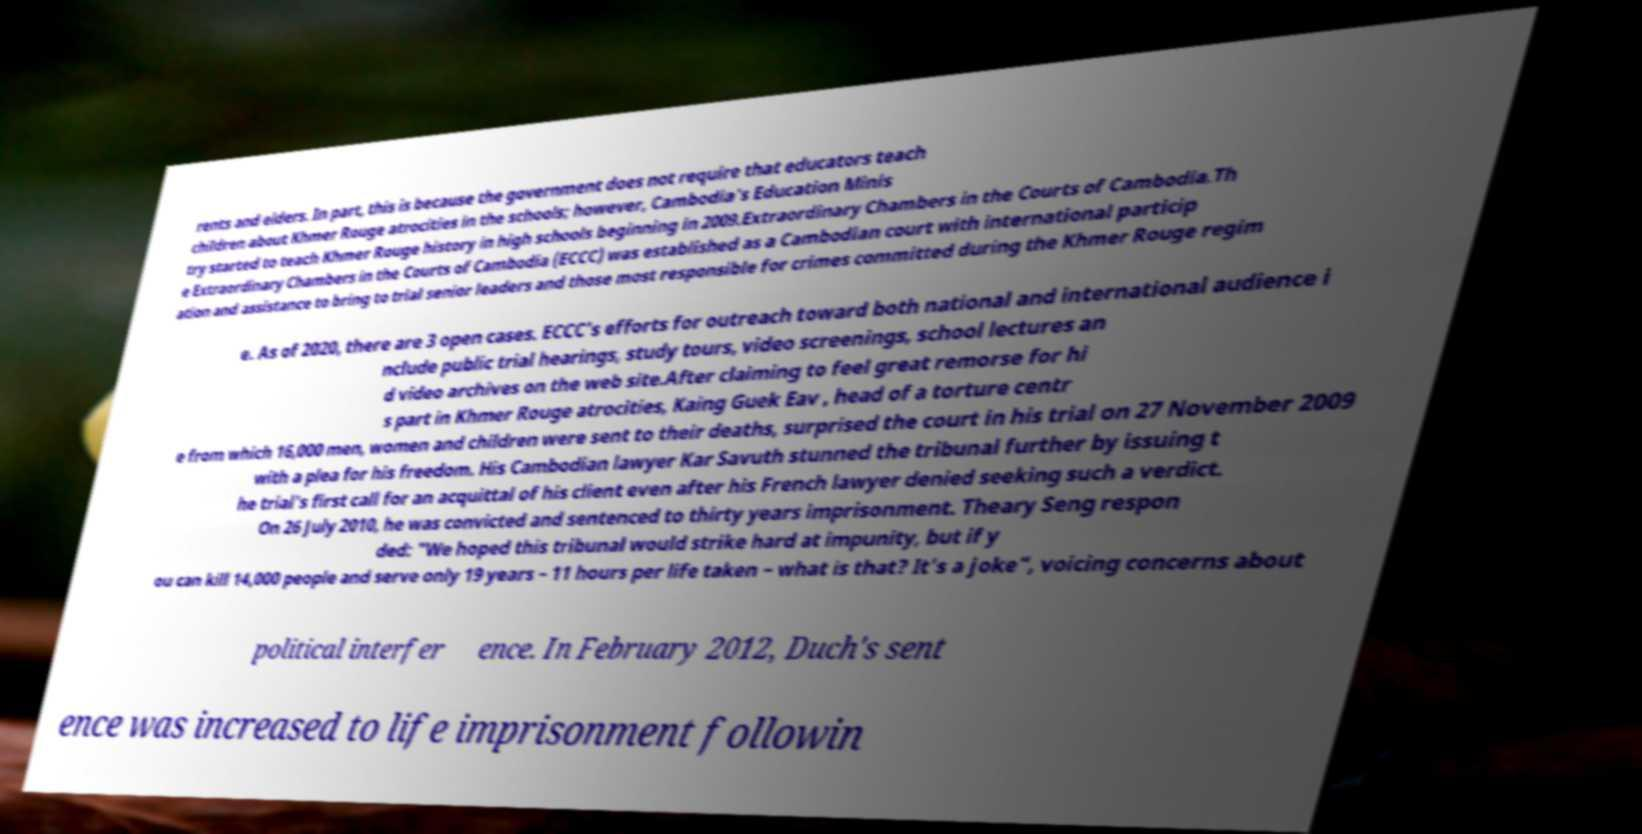What messages or text are displayed in this image? I need them in a readable, typed format. rents and elders. In part, this is because the government does not require that educators teach children about Khmer Rouge atrocities in the schools; however, Cambodia's Education Minis try started to teach Khmer Rouge history in high schools beginning in 2009.Extraordinary Chambers in the Courts of Cambodia.Th e Extraordinary Chambers in the Courts of Cambodia (ECCC) was established as a Cambodian court with international particip ation and assistance to bring to trial senior leaders and those most responsible for crimes committed during the Khmer Rouge regim e. As of 2020, there are 3 open cases. ECCC's efforts for outreach toward both national and international audience i nclude public trial hearings, study tours, video screenings, school lectures an d video archives on the web site.After claiming to feel great remorse for hi s part in Khmer Rouge atrocities, Kaing Guek Eav , head of a torture centr e from which 16,000 men, women and children were sent to their deaths, surprised the court in his trial on 27 November 2009 with a plea for his freedom. His Cambodian lawyer Kar Savuth stunned the tribunal further by issuing t he trial's first call for an acquittal of his client even after his French lawyer denied seeking such a verdict. On 26 July 2010, he was convicted and sentenced to thirty years imprisonment. Theary Seng respon ded: "We hoped this tribunal would strike hard at impunity, but if y ou can kill 14,000 people and serve only 19 years – 11 hours per life taken – what is that? It's a joke", voicing concerns about political interfer ence. In February 2012, Duch's sent ence was increased to life imprisonment followin 